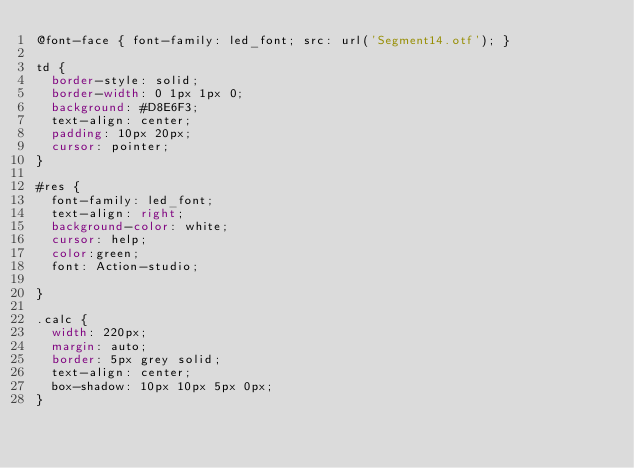<code> <loc_0><loc_0><loc_500><loc_500><_CSS_>@font-face { font-family: led_font; src: url('Segment14.otf'); } 

td {
	border-style: solid;
	border-width: 0 1px 1px 0;
	background: #D8E6F3;
	text-align: center;
	padding: 10px 20px;
	cursor: pointer;
}

#res {
	font-family: led_font;
	text-align: right;
	background-color: white;
	cursor: help;
	color:green;
	font: Action-studio;

}

.calc {
	width: 220px;
	margin: auto;
	border: 5px grey solid;
	text-align: center;
	box-shadow: 10px 10px 5px 0px;
}</code> 